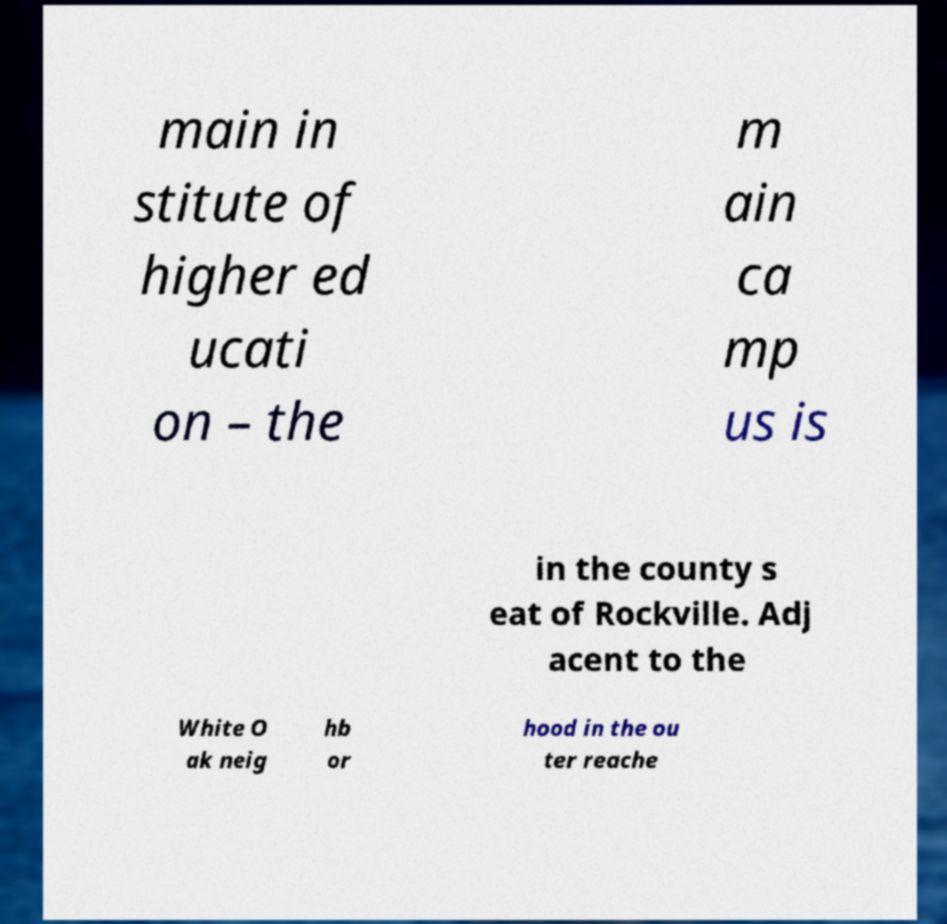There's text embedded in this image that I need extracted. Can you transcribe it verbatim? main in stitute of higher ed ucati on – the m ain ca mp us is in the county s eat of Rockville. Adj acent to the White O ak neig hb or hood in the ou ter reache 